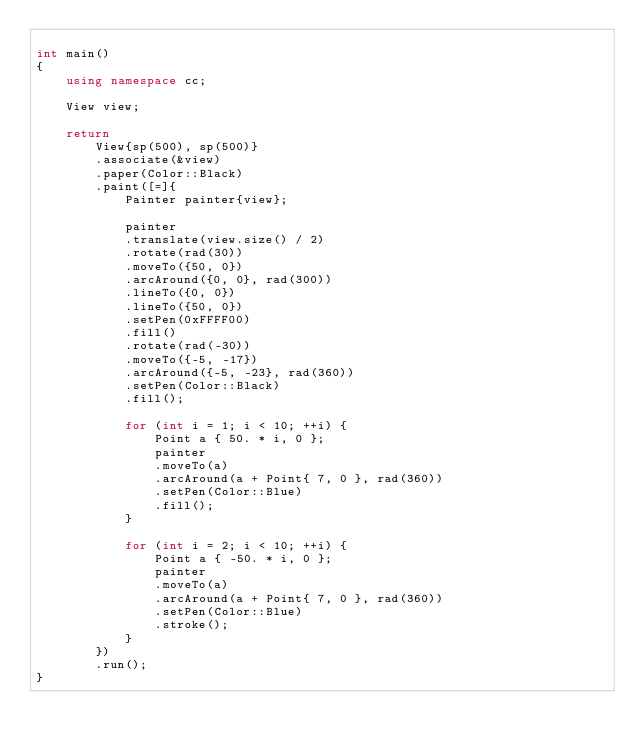<code> <loc_0><loc_0><loc_500><loc_500><_C++_>
int main()
{
    using namespace cc;

    View view;

    return
        View{sp(500), sp(500)}
        .associate(&view)
        .paper(Color::Black)
        .paint([=]{
            Painter painter{view};

            painter
            .translate(view.size() / 2)
            .rotate(rad(30))
            .moveTo({50, 0})
            .arcAround({0, 0}, rad(300))
            .lineTo({0, 0})
            .lineTo({50, 0})
            .setPen(0xFFFF00)
            .fill()
            .rotate(rad(-30))
            .moveTo({-5, -17})
            .arcAround({-5, -23}, rad(360))
            .setPen(Color::Black)
            .fill();

            for (int i = 1; i < 10; ++i) {
                Point a { 50. * i, 0 };
                painter
                .moveTo(a)
                .arcAround(a + Point{ 7, 0 }, rad(360))
                .setPen(Color::Blue)
                .fill();
            }

            for (int i = 2; i < 10; ++i) {
                Point a { -50. * i, 0 };
                painter
                .moveTo(a)
                .arcAround(a + Point{ 7, 0 }, rad(360))
                .setPen(Color::Blue)
                .stroke();
            }
        })
        .run();
}
</code> 